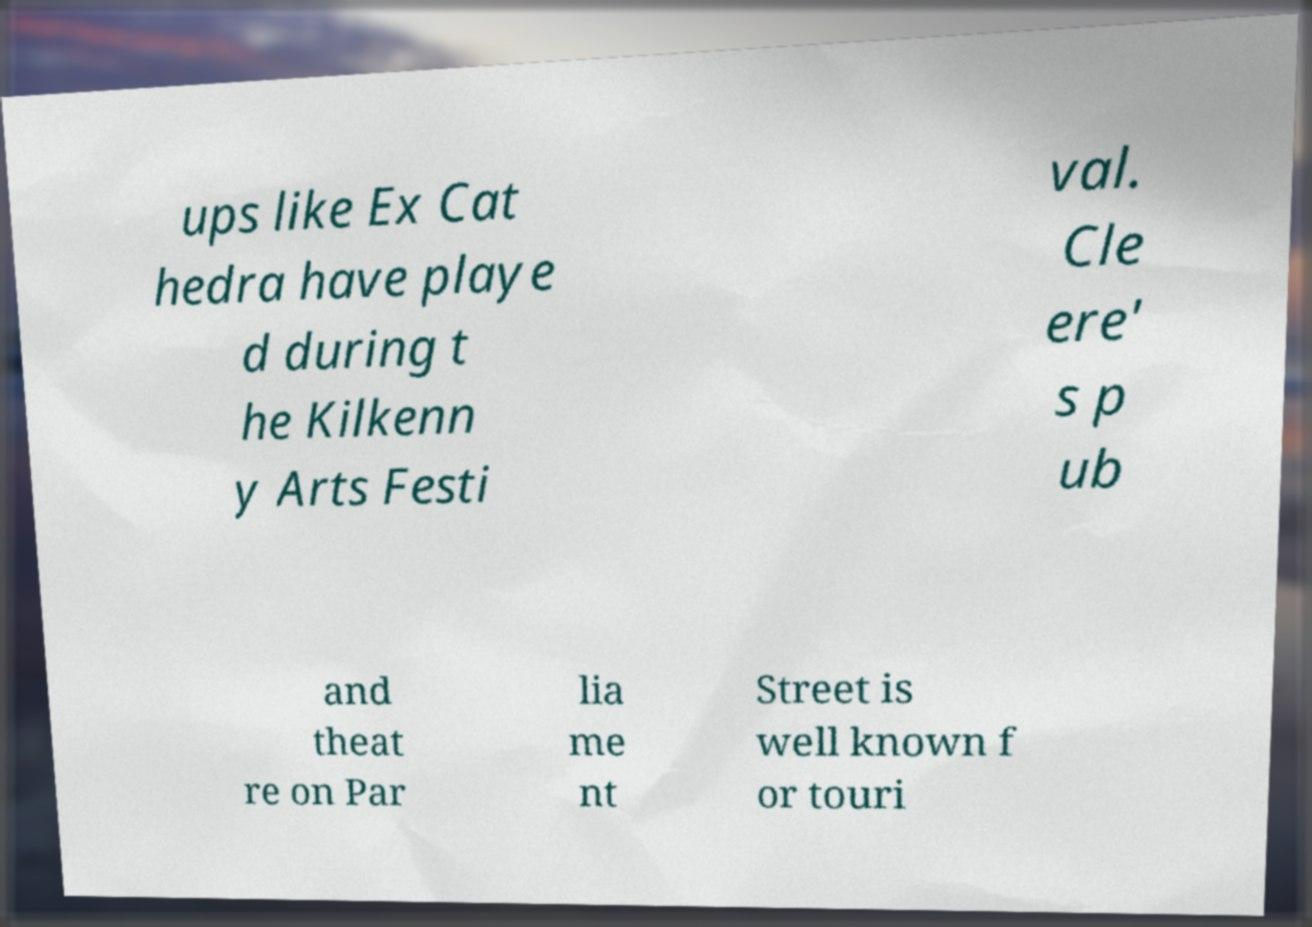What messages or text are displayed in this image? I need them in a readable, typed format. ups like Ex Cat hedra have playe d during t he Kilkenn y Arts Festi val. Cle ere' s p ub and theat re on Par lia me nt Street is well known f or touri 